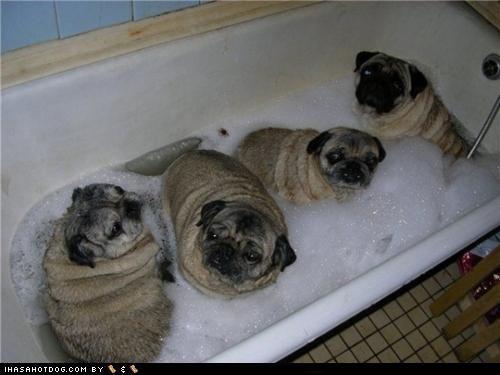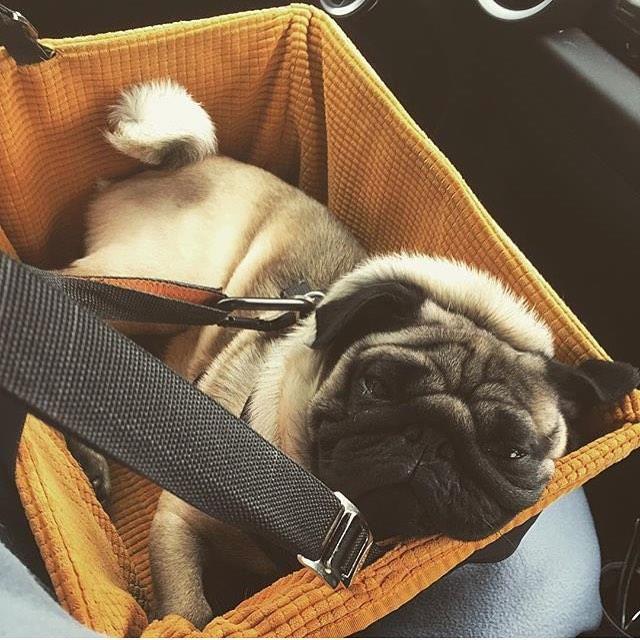The first image is the image on the left, the second image is the image on the right. For the images displayed, is the sentence "Thre are two dogs in total." factually correct? Answer yes or no. No. The first image is the image on the left, the second image is the image on the right. Considering the images on both sides, is "An image shows a pug dog wearing some type of band over its head." valid? Answer yes or no. No. 